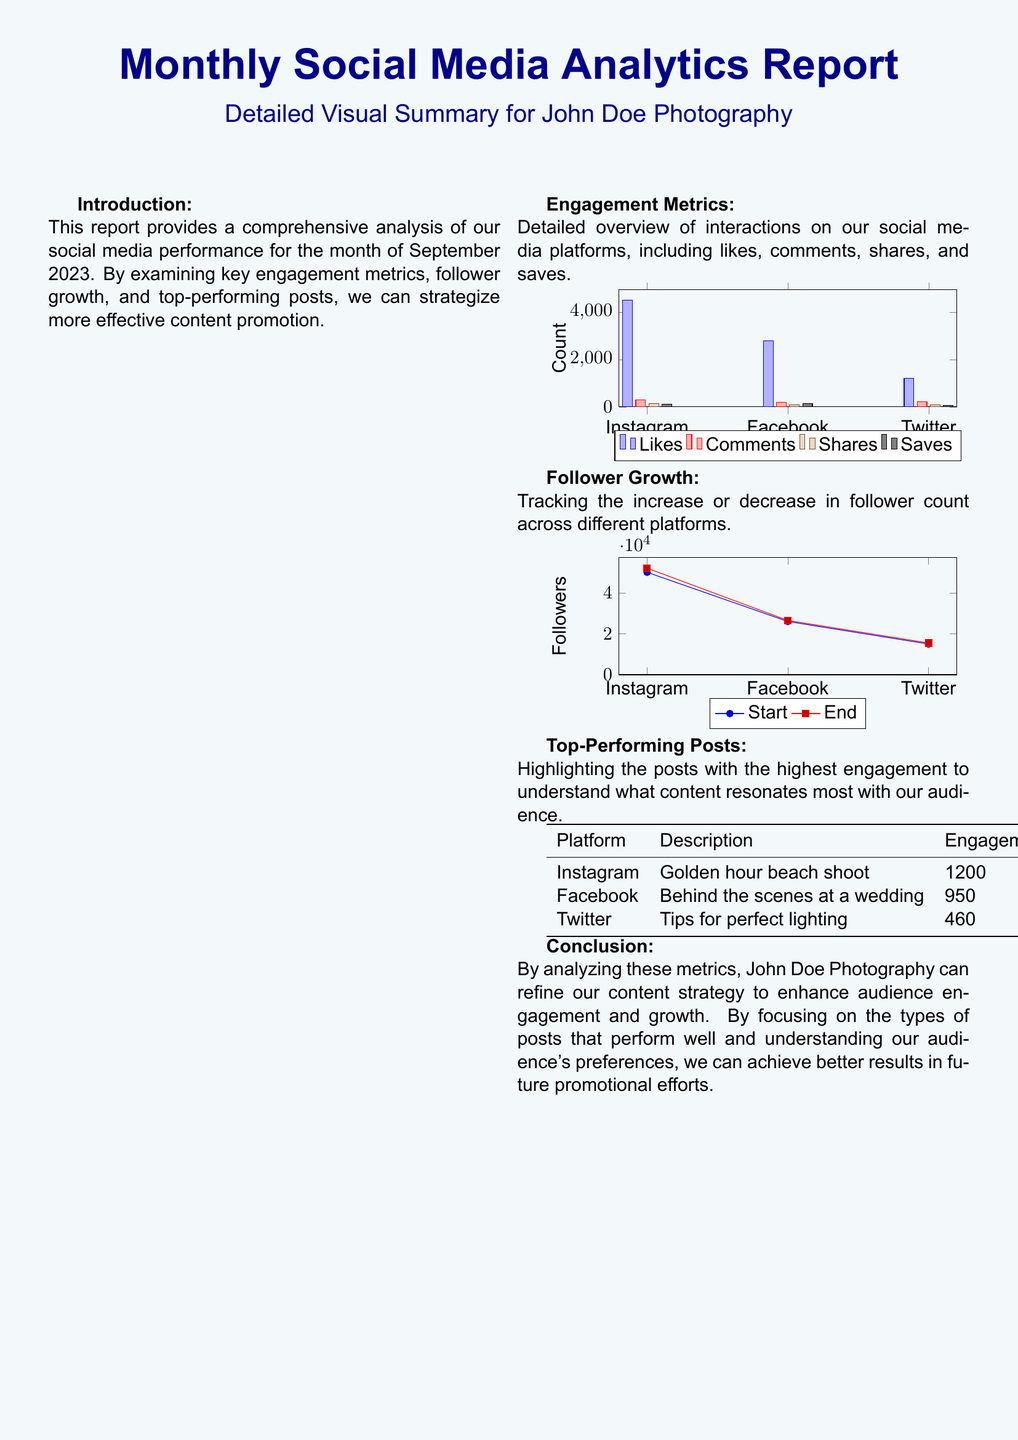what was the total number of likes on Instagram? The total number of likes on Instagram recorded in the document is 4500.
Answer: 4500 how many comments were there on Facebook? The number of comments on Facebook was detailed as 180 in the document.
Answer: 180 what is the follower count on Twitter at the end of the period? The follower count on Twitter at the end of the period was 15500.
Answer: 15500 which post had the highest engagement on Instagram? The post with the highest engagement on Instagram was the "Golden hour beach shoot" with 1200 engagements.
Answer: Golden hour beach shoot what is the total engagement for the top-performing Facebook post? The top-performing Facebook post had an engagement count of 950, which provides insight into its performance.
Answer: 950 how many followers were gained on Instagram from the start to the end of the month? The follower growth on Instagram from start to end was 2000, calculated from the change in the follower count.
Answer: 2000 which social media platform had the least engagement in terms of shares? The platform with the least engagement in terms of shares is Twitter, which had 60 shares.
Answer: Twitter what was the total number of engagements for Twitter's top post? The total number of engagements for Twitter's top post was recorded as 460 in the document.
Answer: 460 